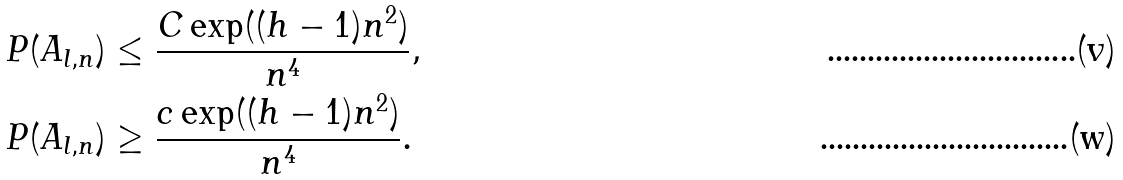Convert formula to latex. <formula><loc_0><loc_0><loc_500><loc_500>P ( A _ { l , n } ) & \leq \frac { C \exp ( ( h - 1 ) n ^ { 2 } ) } { n ^ { 4 } } , \\ P ( A _ { l , n } ) & \geq \frac { c \exp ( ( h - 1 ) n ^ { 2 } ) } { n ^ { 4 } } .</formula> 